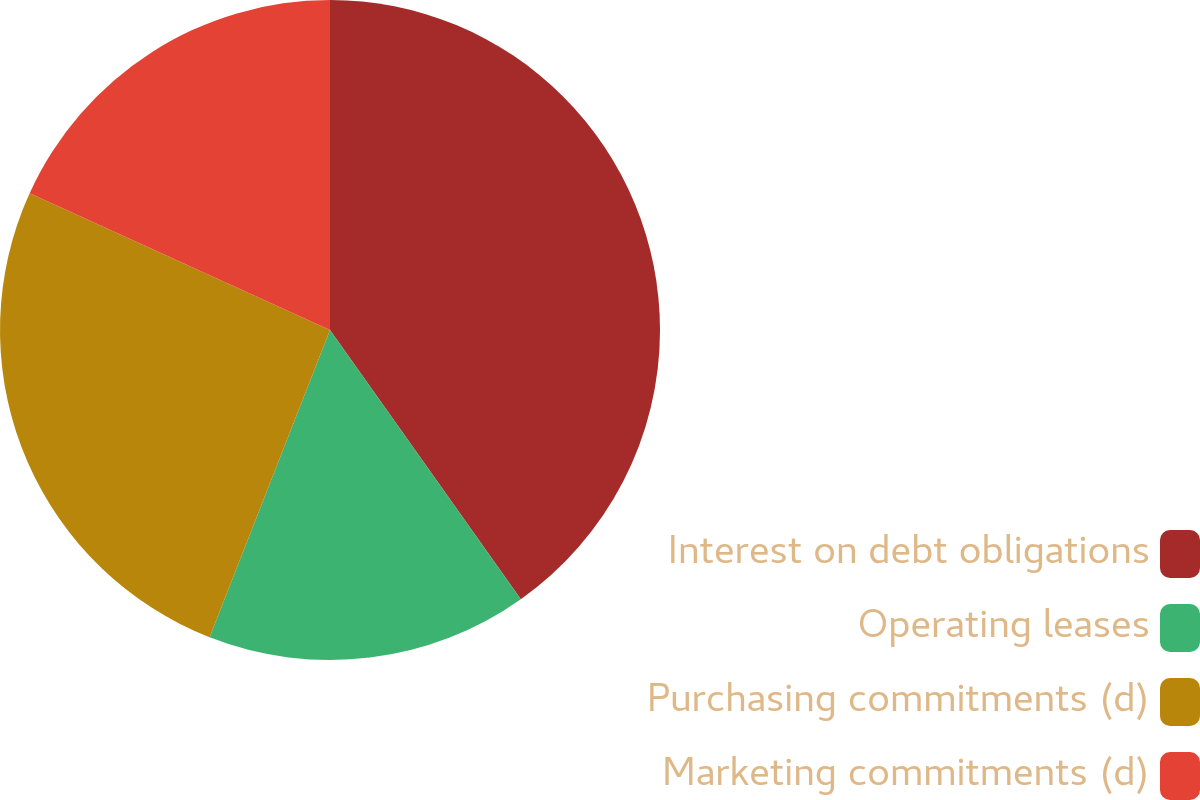<chart> <loc_0><loc_0><loc_500><loc_500><pie_chart><fcel>Interest on debt obligations<fcel>Operating leases<fcel>Purchasing commitments (d)<fcel>Marketing commitments (d)<nl><fcel>40.19%<fcel>15.76%<fcel>25.86%<fcel>18.2%<nl></chart> 